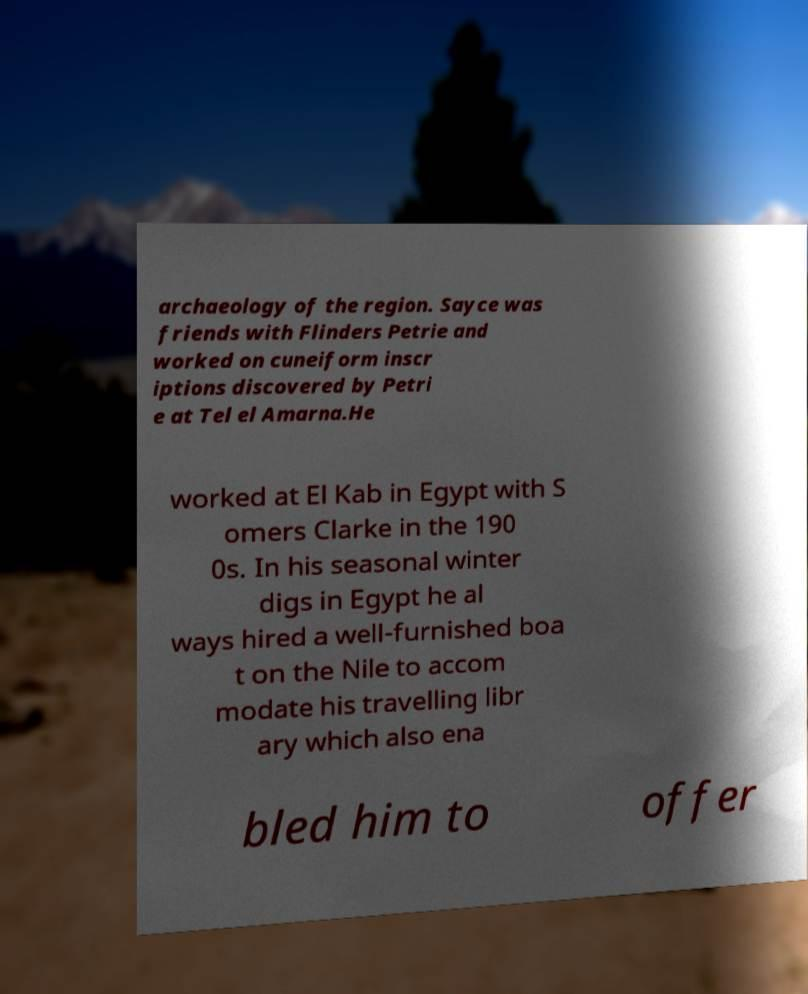Could you assist in decoding the text presented in this image and type it out clearly? archaeology of the region. Sayce was friends with Flinders Petrie and worked on cuneiform inscr iptions discovered by Petri e at Tel el Amarna.He worked at El Kab in Egypt with S omers Clarke in the 190 0s. In his seasonal winter digs in Egypt he al ways hired a well-furnished boa t on the Nile to accom modate his travelling libr ary which also ena bled him to offer 